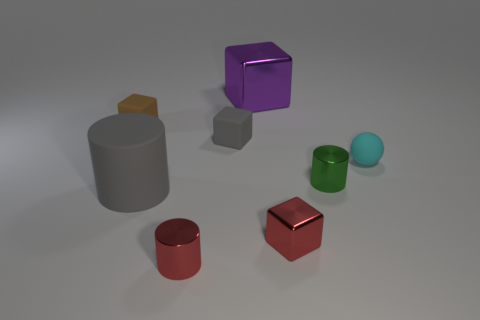Are there the same number of cyan objects that are behind the small gray object and large cubes?
Offer a terse response. No. What number of gray cubes have the same material as the small ball?
Your response must be concise. 1. Are there fewer tiny cyan rubber spheres than red shiny objects?
Give a very brief answer. Yes. There is a big thing that is in front of the tiny rubber ball; does it have the same color as the tiny rubber ball?
Give a very brief answer. No. What number of shiny cubes are behind the rubber thing on the left side of the rubber cylinder that is in front of the big purple metal block?
Offer a very short reply. 1. There is a red cylinder; what number of cylinders are on the right side of it?
Your response must be concise. 1. The other rubber object that is the same shape as the tiny green thing is what color?
Your answer should be very brief. Gray. What material is the thing that is in front of the large gray rubber cylinder and to the right of the large purple cube?
Make the answer very short. Metal. There is a metal block to the right of the purple shiny block; is it the same size as the large gray matte cylinder?
Ensure brevity in your answer.  No. What is the material of the tiny green cylinder?
Provide a succinct answer. Metal. 